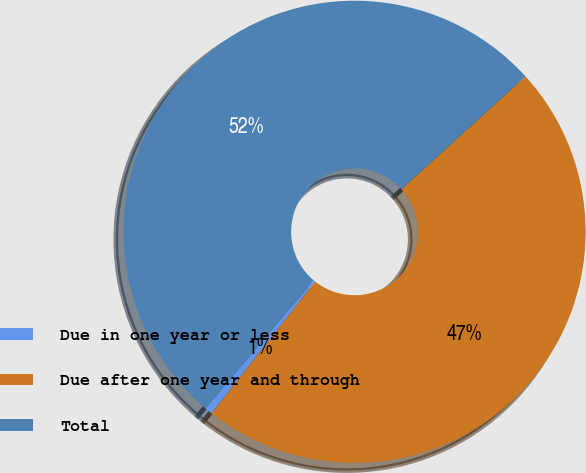Convert chart to OTSL. <chart><loc_0><loc_0><loc_500><loc_500><pie_chart><fcel>Due in one year or less<fcel>Due after one year and through<fcel>Total<nl><fcel>0.55%<fcel>47.36%<fcel>52.1%<nl></chart> 